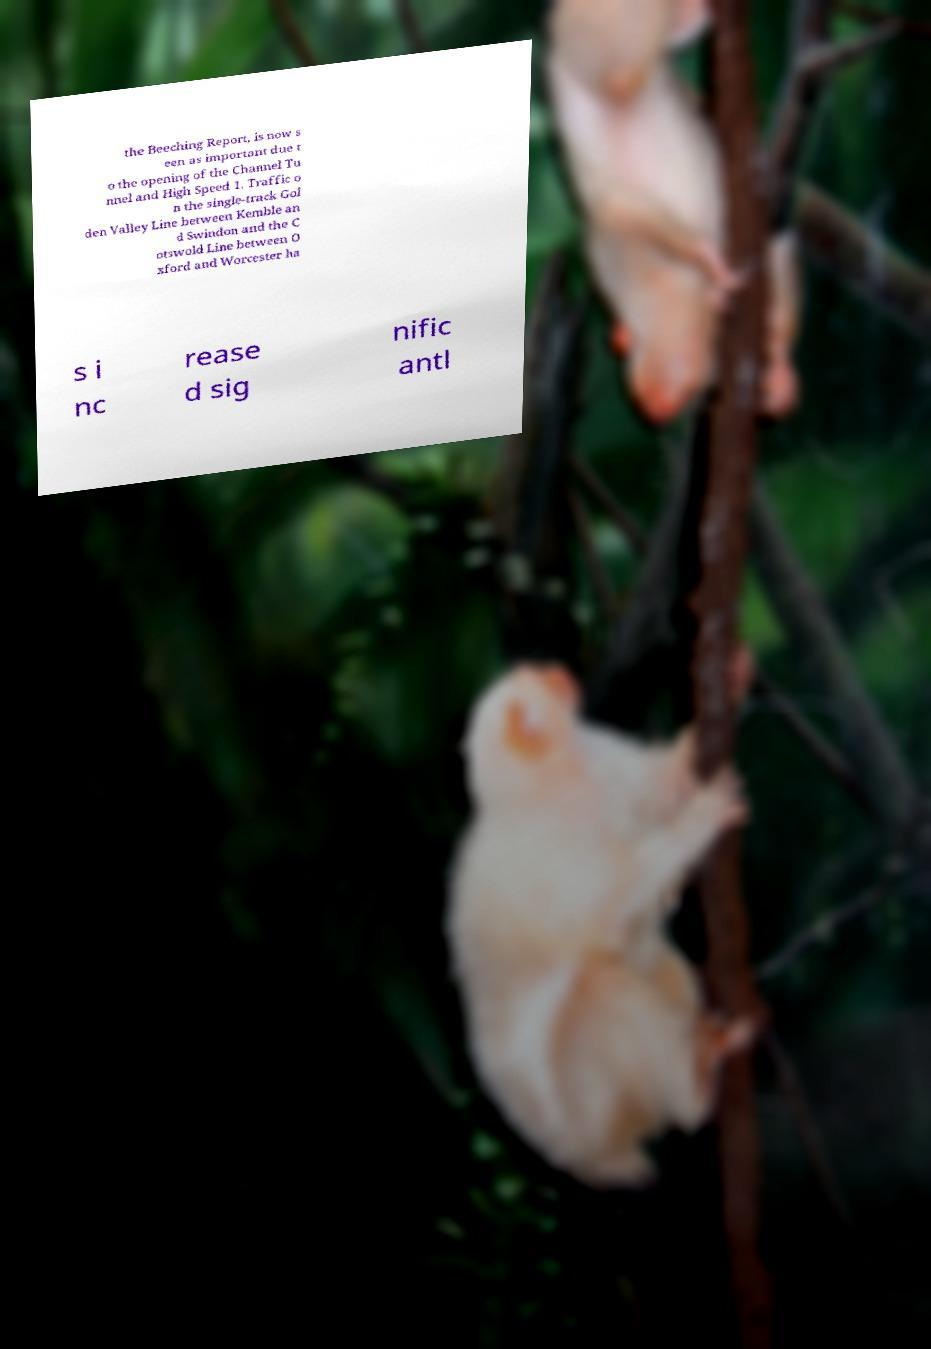I need the written content from this picture converted into text. Can you do that? the Beeching Report, is now s een as important due t o the opening of the Channel Tu nnel and High Speed 1. Traffic o n the single-track Gol den Valley Line between Kemble an d Swindon and the C otswold Line between O xford and Worcester ha s i nc rease d sig nific antl 